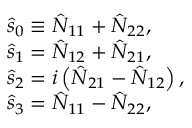<formula> <loc_0><loc_0><loc_500><loc_500>\begin{array} { r l } & { \hat { s } _ { 0 } \equiv \hat { N } _ { 1 1 } + \hat { N } _ { 2 2 } , } \\ & { \hat { s } _ { 1 } = \hat { N } _ { 1 2 } + \hat { N } _ { 2 1 } , } \\ & { \hat { s } _ { 2 } = i \left ( \hat { N } _ { 2 1 } - \hat { N } _ { 1 2 } \right ) , } \\ & { \hat { s } _ { 3 } = \hat { N } _ { 1 1 } - \hat { N } _ { 2 2 } , } \end{array}</formula> 